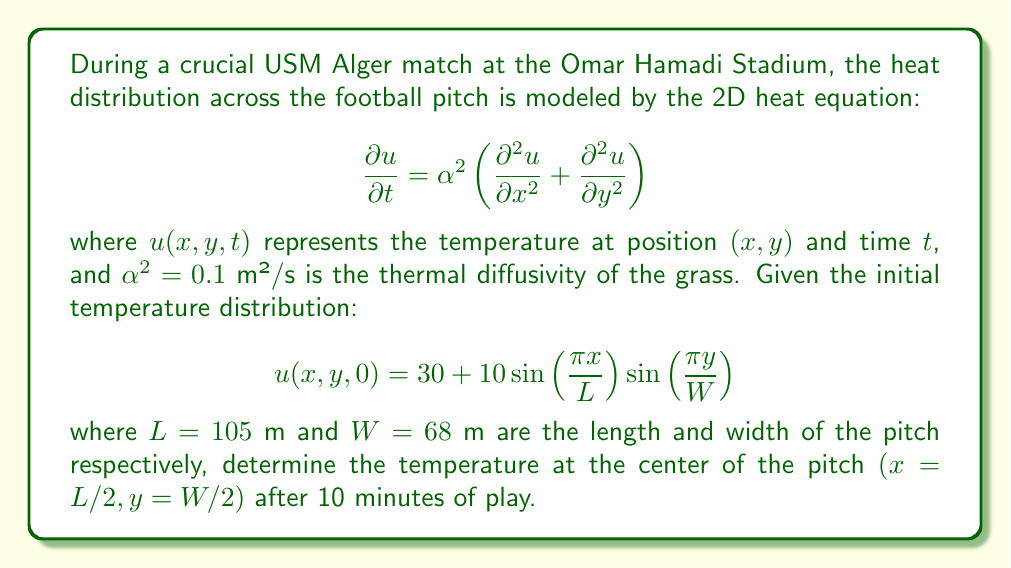Could you help me with this problem? To solve this problem, we'll follow these steps:

1) The general solution to the 2D heat equation with the given initial condition is:

   $$u(x,y,t) = 30 + 10e^{-\alpha^2\pi^2t(\frac{1}{L^2}+\frac{1}{W^2})}\sin\left(\frac{\pi x}{L}\right)\sin\left(\frac{\pi y}{W}\right)$$

2) We need to evaluate this at the center of the pitch $(x=L/2, y=W/2)$ and at $t=10$ minutes $= 600$ seconds:

   $$u(L/2,W/2,600) = 30 + 10e^{-0.1\pi^2(600)(\frac{1}{105^2}+\frac{1}{68^2})}\sin\left(\frac{\pi}{2}\right)\sin\left(\frac{\pi}{2}\right)$$

3) Simplify:
   $\sin(\frac{\pi}{2}) = 1$, so:

   $$u(L/2,W/2,600) = 30 + 10e^{-0.1\pi^2(600)(\frac{1}{105^2}+\frac{1}{68^2})}$$

4) Calculate the exponent:
   $$-0.1\pi^2(600)(\frac{1}{105^2}+\frac{1}{68^2}) \approx -0.0535$$

5) Therefore:

   $$u(L/2,W/2,600) = 30 + 10e^{-0.0535} \approx 30 + 9.48 = 39.48$$

Thus, the temperature at the center of the pitch after 10 minutes is approximately 39.48°C.
Answer: 39.48°C 